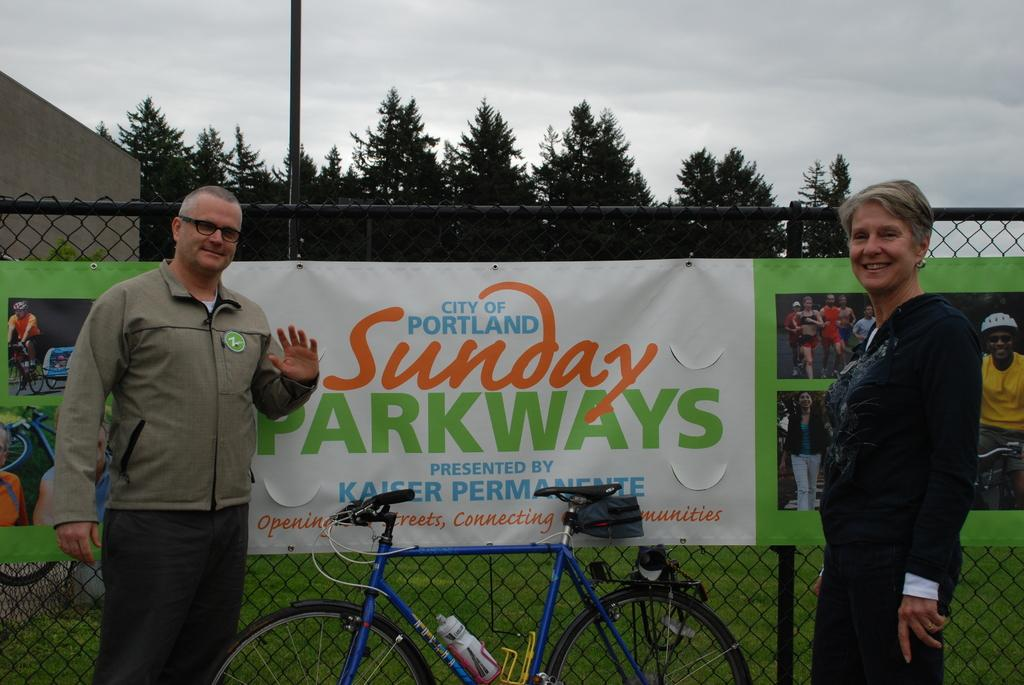What is the weather like in the image? The weather in the image suggests a cloudy day, as there are clouds visible. What type of vegetation can be seen in the image? Trees are visible in the image. What is hanging on the net in the image? There are banners on the net. Who is present in the image? There is a woman and a man in the image. What are the woman and man standing near? The woman and man are standing near a bicycle. What type of market can be seen in the image? There is no market visible in the image. 